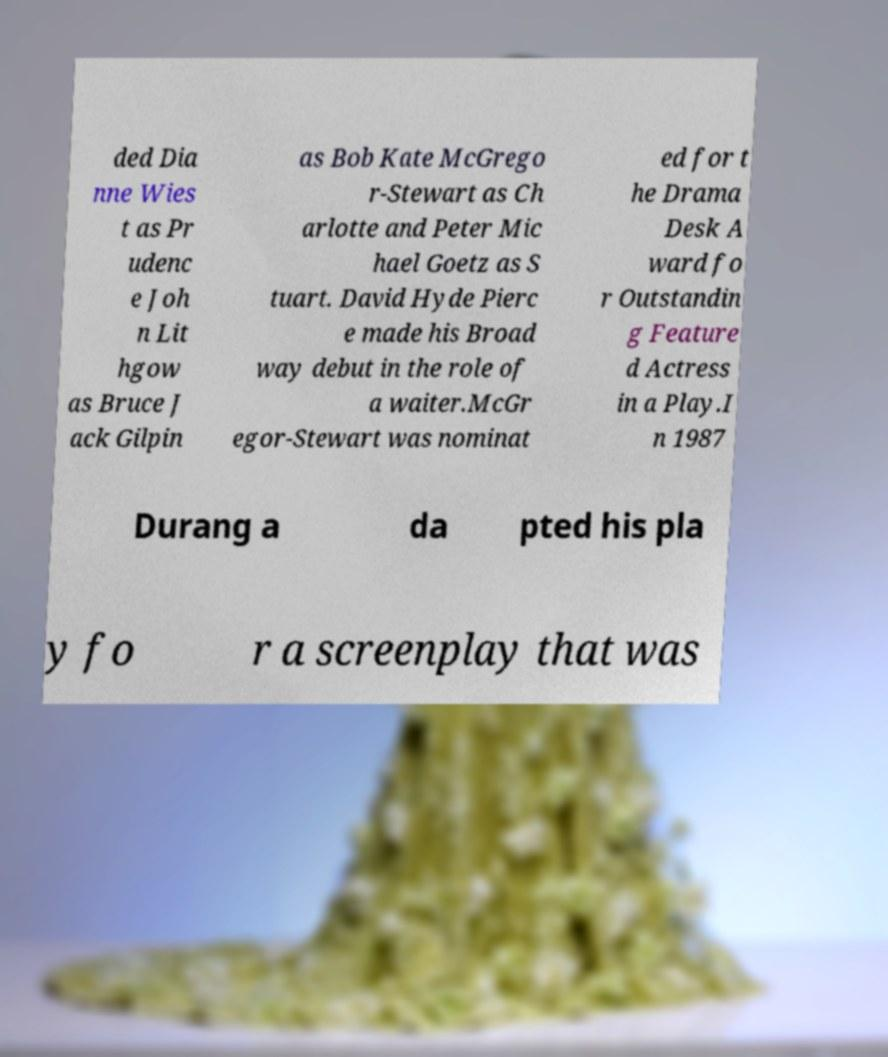Please read and relay the text visible in this image. What does it say? ded Dia nne Wies t as Pr udenc e Joh n Lit hgow as Bruce J ack Gilpin as Bob Kate McGrego r-Stewart as Ch arlotte and Peter Mic hael Goetz as S tuart. David Hyde Pierc e made his Broad way debut in the role of a waiter.McGr egor-Stewart was nominat ed for t he Drama Desk A ward fo r Outstandin g Feature d Actress in a Play.I n 1987 Durang a da pted his pla y fo r a screenplay that was 